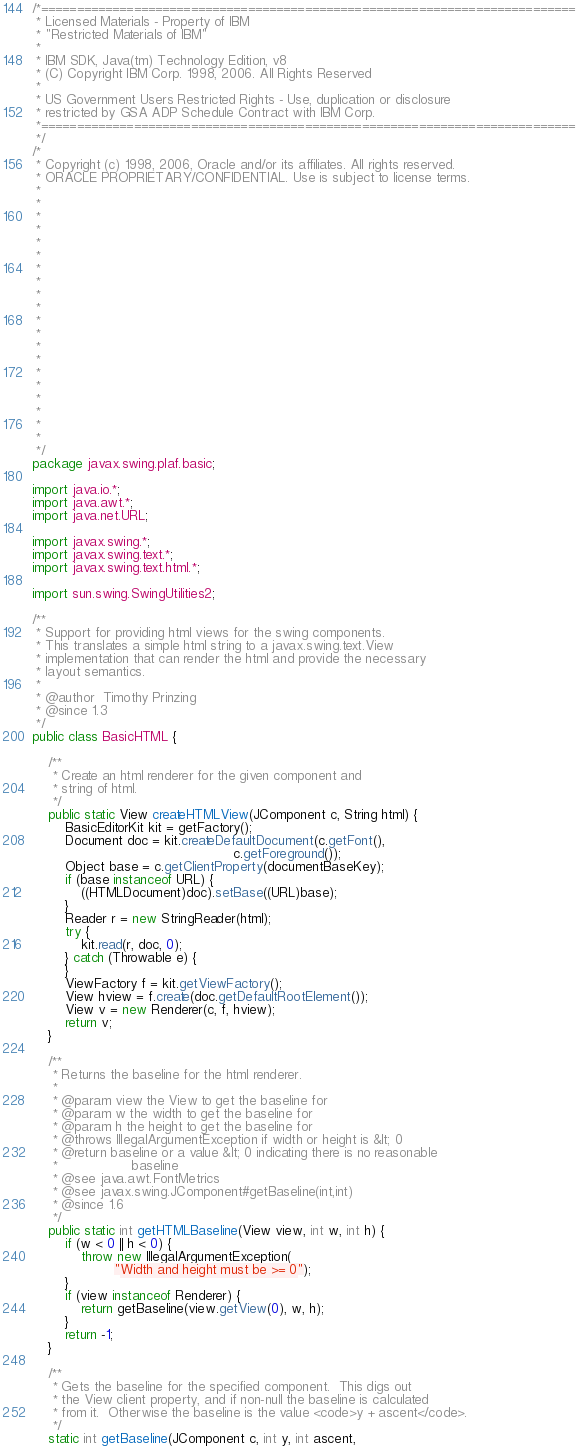<code> <loc_0><loc_0><loc_500><loc_500><_Java_>/*===========================================================================
 * Licensed Materials - Property of IBM
 * "Restricted Materials of IBM"
 * 
 * IBM SDK, Java(tm) Technology Edition, v8
 * (C) Copyright IBM Corp. 1998, 2006. All Rights Reserved
 *
 * US Government Users Restricted Rights - Use, duplication or disclosure
 * restricted by GSA ADP Schedule Contract with IBM Corp.
 *===========================================================================
 */
/*
 * Copyright (c) 1998, 2006, Oracle and/or its affiliates. All rights reserved.
 * ORACLE PROPRIETARY/CONFIDENTIAL. Use is subject to license terms.
 *
 *
 *
 *
 *
 *
 *
 *
 *
 *
 *
 *
 *
 *
 *
 *
 *
 *
 *
 *
 */
package javax.swing.plaf.basic;

import java.io.*;
import java.awt.*;
import java.net.URL;

import javax.swing.*;
import javax.swing.text.*;
import javax.swing.text.html.*;

import sun.swing.SwingUtilities2;

/**
 * Support for providing html views for the swing components.
 * This translates a simple html string to a javax.swing.text.View
 * implementation that can render the html and provide the necessary
 * layout semantics.
 *
 * @author  Timothy Prinzing
 * @since 1.3
 */
public class BasicHTML {

    /**
     * Create an html renderer for the given component and
     * string of html.
     */
    public static View createHTMLView(JComponent c, String html) {
        BasicEditorKit kit = getFactory();
        Document doc = kit.createDefaultDocument(c.getFont(),
                                                 c.getForeground());
        Object base = c.getClientProperty(documentBaseKey);
        if (base instanceof URL) {
            ((HTMLDocument)doc).setBase((URL)base);
        }
        Reader r = new StringReader(html);
        try {
            kit.read(r, doc, 0);
        } catch (Throwable e) {
        }
        ViewFactory f = kit.getViewFactory();
        View hview = f.create(doc.getDefaultRootElement());
        View v = new Renderer(c, f, hview);
        return v;
    }

    /**
     * Returns the baseline for the html renderer.
     *
     * @param view the View to get the baseline for
     * @param w the width to get the baseline for
     * @param h the height to get the baseline for
     * @throws IllegalArgumentException if width or height is &lt; 0
     * @return baseline or a value &lt; 0 indicating there is no reasonable
     *                  baseline
     * @see java.awt.FontMetrics
     * @see javax.swing.JComponent#getBaseline(int,int)
     * @since 1.6
     */
    public static int getHTMLBaseline(View view, int w, int h) {
        if (w < 0 || h < 0) {
            throw new IllegalArgumentException(
                    "Width and height must be >= 0");
        }
        if (view instanceof Renderer) {
            return getBaseline(view.getView(0), w, h);
        }
        return -1;
    }

    /**
     * Gets the baseline for the specified component.  This digs out
     * the View client property, and if non-null the baseline is calculated
     * from it.  Otherwise the baseline is the value <code>y + ascent</code>.
     */
    static int getBaseline(JComponent c, int y, int ascent,</code> 